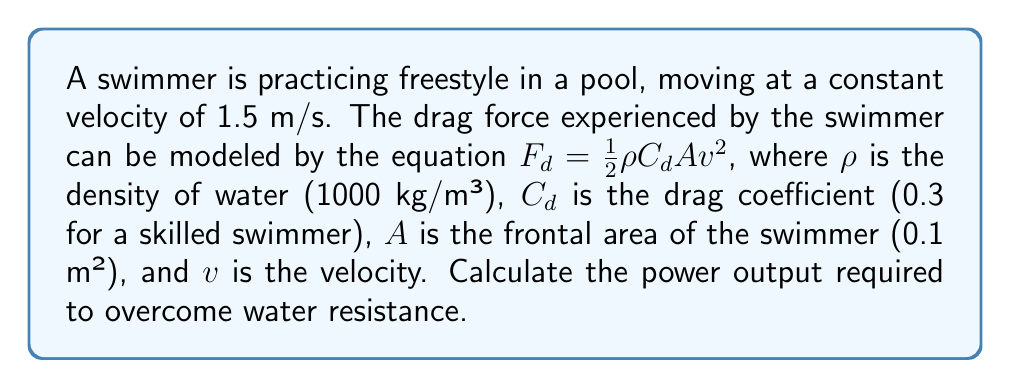Teach me how to tackle this problem. To solve this problem, we'll follow these steps:

1. Calculate the drag force using the given equation:
   $F_d = \frac{1}{2}\rho C_d A v^2$

2. Substitute the given values:
   $\rho = 1000$ kg/m³
   $C_d = 0.3$
   $A = 0.1$ m²
   $v = 1.5$ m/s

3. Calculate the drag force:
   $F_d = \frac{1}{2} \cdot 1000 \cdot 0.3 \cdot 0.1 \cdot 1.5^2$
   $F_d = 50 \cdot 2.25 = 112.5$ N

4. Calculate the power output:
   Power = Force × Velocity
   $P = F_d \cdot v$
   $P = 112.5 \cdot 1.5 = 168.75$ W

Therefore, the power output required to overcome water resistance is 168.75 watts.
Answer: 168.75 W 